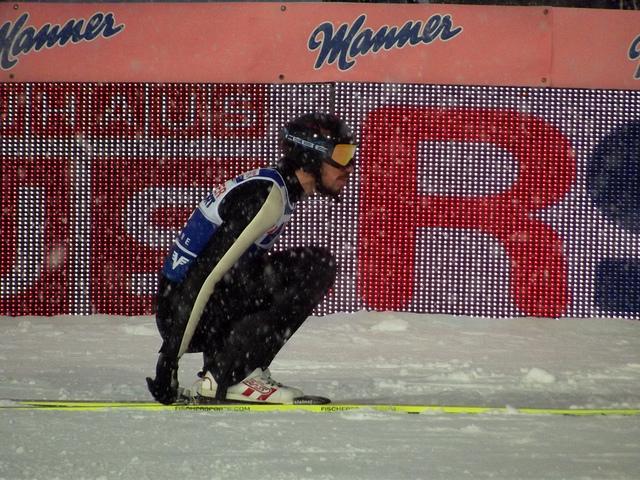Is this a winter sport?
Answer briefly. Yes. What big letter is in red?
Answer briefly. R. What word is at the top of the picture?
Short answer required. Manner. 